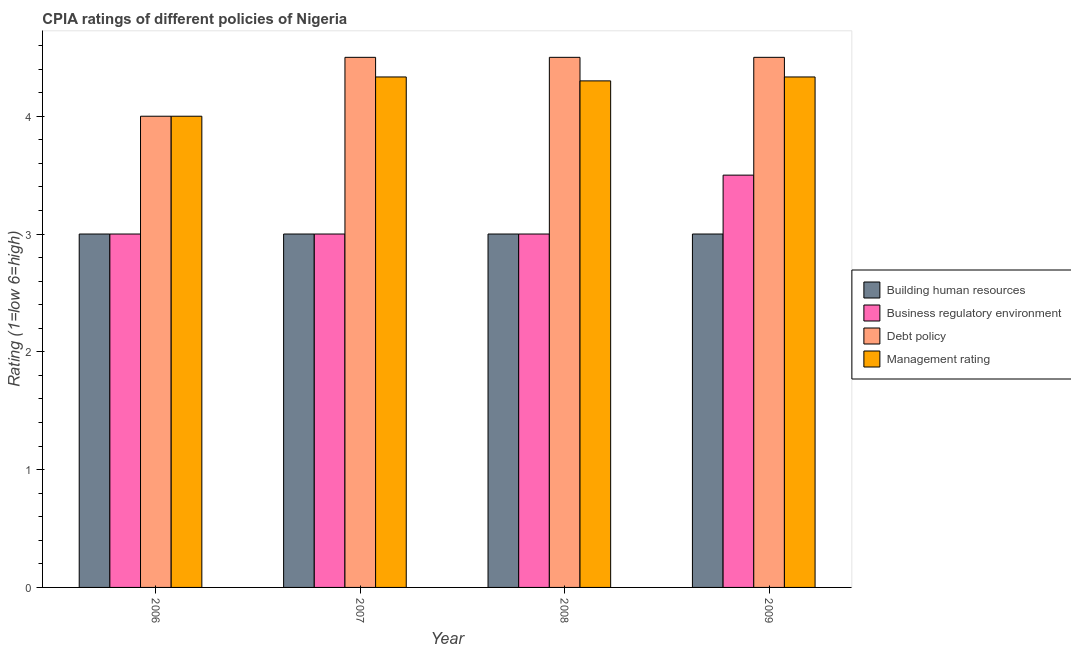How many different coloured bars are there?
Ensure brevity in your answer.  4. How many groups of bars are there?
Your answer should be compact. 4. Are the number of bars on each tick of the X-axis equal?
Make the answer very short. Yes. What is the label of the 1st group of bars from the left?
Your answer should be very brief. 2006. In how many cases, is the number of bars for a given year not equal to the number of legend labels?
Your answer should be compact. 0. In which year was the cpia rating of debt policy maximum?
Your response must be concise. 2007. What is the difference between the cpia rating of building human resources in 2006 and that in 2008?
Your answer should be very brief. 0. What is the difference between the cpia rating of management in 2007 and the cpia rating of building human resources in 2006?
Offer a terse response. 0.33. What is the average cpia rating of management per year?
Offer a very short reply. 4.24. In the year 2007, what is the difference between the cpia rating of debt policy and cpia rating of business regulatory environment?
Give a very brief answer. 0. What is the ratio of the cpia rating of building human resources in 2006 to that in 2009?
Offer a terse response. 1. Is the difference between the cpia rating of business regulatory environment in 2006 and 2009 greater than the difference between the cpia rating of management in 2006 and 2009?
Provide a succinct answer. No. What is the difference between the highest and the second highest cpia rating of building human resources?
Provide a succinct answer. 0. What is the difference between the highest and the lowest cpia rating of debt policy?
Your answer should be very brief. 0.5. In how many years, is the cpia rating of debt policy greater than the average cpia rating of debt policy taken over all years?
Provide a succinct answer. 3. Is the sum of the cpia rating of management in 2007 and 2009 greater than the maximum cpia rating of business regulatory environment across all years?
Make the answer very short. Yes. What does the 2nd bar from the left in 2006 represents?
Give a very brief answer. Business regulatory environment. What does the 3rd bar from the right in 2007 represents?
Your answer should be very brief. Business regulatory environment. How many years are there in the graph?
Offer a terse response. 4. What is the difference between two consecutive major ticks on the Y-axis?
Offer a terse response. 1. Are the values on the major ticks of Y-axis written in scientific E-notation?
Your answer should be compact. No. How many legend labels are there?
Your response must be concise. 4. How are the legend labels stacked?
Provide a short and direct response. Vertical. What is the title of the graph?
Offer a terse response. CPIA ratings of different policies of Nigeria. What is the label or title of the X-axis?
Give a very brief answer. Year. What is the Rating (1=low 6=high) in Business regulatory environment in 2006?
Your response must be concise. 3. What is the Rating (1=low 6=high) of Debt policy in 2006?
Make the answer very short. 4. What is the Rating (1=low 6=high) in Building human resources in 2007?
Provide a succinct answer. 3. What is the Rating (1=low 6=high) in Debt policy in 2007?
Ensure brevity in your answer.  4.5. What is the Rating (1=low 6=high) in Management rating in 2007?
Provide a short and direct response. 4.33. What is the Rating (1=low 6=high) of Building human resources in 2008?
Your answer should be very brief. 3. What is the Rating (1=low 6=high) in Debt policy in 2008?
Offer a terse response. 4.5. What is the Rating (1=low 6=high) of Building human resources in 2009?
Ensure brevity in your answer.  3. What is the Rating (1=low 6=high) of Business regulatory environment in 2009?
Provide a short and direct response. 3.5. What is the Rating (1=low 6=high) of Debt policy in 2009?
Make the answer very short. 4.5. What is the Rating (1=low 6=high) in Management rating in 2009?
Ensure brevity in your answer.  4.33. Across all years, what is the maximum Rating (1=low 6=high) of Business regulatory environment?
Offer a terse response. 3.5. Across all years, what is the maximum Rating (1=low 6=high) in Debt policy?
Keep it short and to the point. 4.5. Across all years, what is the maximum Rating (1=low 6=high) of Management rating?
Keep it short and to the point. 4.33. Across all years, what is the minimum Rating (1=low 6=high) of Building human resources?
Your answer should be very brief. 3. What is the total Rating (1=low 6=high) in Building human resources in the graph?
Keep it short and to the point. 12. What is the total Rating (1=low 6=high) of Management rating in the graph?
Make the answer very short. 16.97. What is the difference between the Rating (1=low 6=high) of Business regulatory environment in 2006 and that in 2007?
Provide a succinct answer. 0. What is the difference between the Rating (1=low 6=high) in Debt policy in 2006 and that in 2007?
Your response must be concise. -0.5. What is the difference between the Rating (1=low 6=high) of Business regulatory environment in 2006 and that in 2008?
Give a very brief answer. 0. What is the difference between the Rating (1=low 6=high) of Debt policy in 2006 and that in 2008?
Keep it short and to the point. -0.5. What is the difference between the Rating (1=low 6=high) in Management rating in 2006 and that in 2008?
Keep it short and to the point. -0.3. What is the difference between the Rating (1=low 6=high) of Business regulatory environment in 2006 and that in 2009?
Make the answer very short. -0.5. What is the difference between the Rating (1=low 6=high) of Management rating in 2006 and that in 2009?
Offer a very short reply. -0.33. What is the difference between the Rating (1=low 6=high) in Building human resources in 2007 and that in 2008?
Your answer should be very brief. 0. What is the difference between the Rating (1=low 6=high) in Debt policy in 2007 and that in 2008?
Keep it short and to the point. 0. What is the difference between the Rating (1=low 6=high) in Management rating in 2007 and that in 2008?
Offer a terse response. 0.03. What is the difference between the Rating (1=low 6=high) of Building human resources in 2007 and that in 2009?
Your response must be concise. 0. What is the difference between the Rating (1=low 6=high) in Debt policy in 2007 and that in 2009?
Make the answer very short. 0. What is the difference between the Rating (1=low 6=high) of Business regulatory environment in 2008 and that in 2009?
Keep it short and to the point. -0.5. What is the difference between the Rating (1=low 6=high) in Debt policy in 2008 and that in 2009?
Your answer should be very brief. 0. What is the difference between the Rating (1=low 6=high) in Management rating in 2008 and that in 2009?
Offer a terse response. -0.03. What is the difference between the Rating (1=low 6=high) of Building human resources in 2006 and the Rating (1=low 6=high) of Management rating in 2007?
Your answer should be compact. -1.33. What is the difference between the Rating (1=low 6=high) of Business regulatory environment in 2006 and the Rating (1=low 6=high) of Debt policy in 2007?
Your response must be concise. -1.5. What is the difference between the Rating (1=low 6=high) in Business regulatory environment in 2006 and the Rating (1=low 6=high) in Management rating in 2007?
Provide a short and direct response. -1.33. What is the difference between the Rating (1=low 6=high) of Building human resources in 2006 and the Rating (1=low 6=high) of Business regulatory environment in 2008?
Give a very brief answer. 0. What is the difference between the Rating (1=low 6=high) in Business regulatory environment in 2006 and the Rating (1=low 6=high) in Management rating in 2008?
Your response must be concise. -1.3. What is the difference between the Rating (1=low 6=high) of Debt policy in 2006 and the Rating (1=low 6=high) of Management rating in 2008?
Your response must be concise. -0.3. What is the difference between the Rating (1=low 6=high) of Building human resources in 2006 and the Rating (1=low 6=high) of Business regulatory environment in 2009?
Ensure brevity in your answer.  -0.5. What is the difference between the Rating (1=low 6=high) of Building human resources in 2006 and the Rating (1=low 6=high) of Debt policy in 2009?
Keep it short and to the point. -1.5. What is the difference between the Rating (1=low 6=high) of Building human resources in 2006 and the Rating (1=low 6=high) of Management rating in 2009?
Keep it short and to the point. -1.33. What is the difference between the Rating (1=low 6=high) in Business regulatory environment in 2006 and the Rating (1=low 6=high) in Debt policy in 2009?
Provide a short and direct response. -1.5. What is the difference between the Rating (1=low 6=high) of Business regulatory environment in 2006 and the Rating (1=low 6=high) of Management rating in 2009?
Your answer should be compact. -1.33. What is the difference between the Rating (1=low 6=high) in Debt policy in 2006 and the Rating (1=low 6=high) in Management rating in 2009?
Provide a short and direct response. -0.33. What is the difference between the Rating (1=low 6=high) of Building human resources in 2007 and the Rating (1=low 6=high) of Business regulatory environment in 2008?
Give a very brief answer. 0. What is the difference between the Rating (1=low 6=high) in Building human resources in 2007 and the Rating (1=low 6=high) in Management rating in 2008?
Offer a very short reply. -1.3. What is the difference between the Rating (1=low 6=high) in Building human resources in 2007 and the Rating (1=low 6=high) in Management rating in 2009?
Provide a succinct answer. -1.33. What is the difference between the Rating (1=low 6=high) in Business regulatory environment in 2007 and the Rating (1=low 6=high) in Debt policy in 2009?
Your answer should be compact. -1.5. What is the difference between the Rating (1=low 6=high) in Business regulatory environment in 2007 and the Rating (1=low 6=high) in Management rating in 2009?
Give a very brief answer. -1.33. What is the difference between the Rating (1=low 6=high) of Building human resources in 2008 and the Rating (1=low 6=high) of Business regulatory environment in 2009?
Your answer should be compact. -0.5. What is the difference between the Rating (1=low 6=high) in Building human resources in 2008 and the Rating (1=low 6=high) in Debt policy in 2009?
Provide a succinct answer. -1.5. What is the difference between the Rating (1=low 6=high) of Building human resources in 2008 and the Rating (1=low 6=high) of Management rating in 2009?
Give a very brief answer. -1.33. What is the difference between the Rating (1=low 6=high) of Business regulatory environment in 2008 and the Rating (1=low 6=high) of Management rating in 2009?
Your response must be concise. -1.33. What is the average Rating (1=low 6=high) of Business regulatory environment per year?
Keep it short and to the point. 3.12. What is the average Rating (1=low 6=high) of Debt policy per year?
Your answer should be very brief. 4.38. What is the average Rating (1=low 6=high) in Management rating per year?
Offer a very short reply. 4.24. In the year 2006, what is the difference between the Rating (1=low 6=high) in Building human resources and Rating (1=low 6=high) in Business regulatory environment?
Give a very brief answer. 0. In the year 2006, what is the difference between the Rating (1=low 6=high) of Business regulatory environment and Rating (1=low 6=high) of Debt policy?
Offer a terse response. -1. In the year 2007, what is the difference between the Rating (1=low 6=high) of Building human resources and Rating (1=low 6=high) of Business regulatory environment?
Keep it short and to the point. 0. In the year 2007, what is the difference between the Rating (1=low 6=high) in Building human resources and Rating (1=low 6=high) in Debt policy?
Your answer should be compact. -1.5. In the year 2007, what is the difference between the Rating (1=low 6=high) of Building human resources and Rating (1=low 6=high) of Management rating?
Your response must be concise. -1.33. In the year 2007, what is the difference between the Rating (1=low 6=high) in Business regulatory environment and Rating (1=low 6=high) in Management rating?
Offer a very short reply. -1.33. In the year 2008, what is the difference between the Rating (1=low 6=high) in Building human resources and Rating (1=low 6=high) in Debt policy?
Keep it short and to the point. -1.5. In the year 2008, what is the difference between the Rating (1=low 6=high) in Building human resources and Rating (1=low 6=high) in Management rating?
Offer a very short reply. -1.3. In the year 2008, what is the difference between the Rating (1=low 6=high) of Business regulatory environment and Rating (1=low 6=high) of Management rating?
Offer a terse response. -1.3. In the year 2009, what is the difference between the Rating (1=low 6=high) of Building human resources and Rating (1=low 6=high) of Debt policy?
Give a very brief answer. -1.5. In the year 2009, what is the difference between the Rating (1=low 6=high) in Building human resources and Rating (1=low 6=high) in Management rating?
Offer a terse response. -1.33. In the year 2009, what is the difference between the Rating (1=low 6=high) of Business regulatory environment and Rating (1=low 6=high) of Management rating?
Provide a short and direct response. -0.83. In the year 2009, what is the difference between the Rating (1=low 6=high) of Debt policy and Rating (1=low 6=high) of Management rating?
Your response must be concise. 0.17. What is the ratio of the Rating (1=low 6=high) of Business regulatory environment in 2006 to that in 2007?
Offer a terse response. 1. What is the ratio of the Rating (1=low 6=high) of Debt policy in 2006 to that in 2007?
Your answer should be compact. 0.89. What is the ratio of the Rating (1=low 6=high) in Management rating in 2006 to that in 2007?
Offer a terse response. 0.92. What is the ratio of the Rating (1=low 6=high) in Building human resources in 2006 to that in 2008?
Provide a succinct answer. 1. What is the ratio of the Rating (1=low 6=high) in Business regulatory environment in 2006 to that in 2008?
Your answer should be very brief. 1. What is the ratio of the Rating (1=low 6=high) of Management rating in 2006 to that in 2008?
Offer a very short reply. 0.93. What is the ratio of the Rating (1=low 6=high) of Building human resources in 2006 to that in 2009?
Your response must be concise. 1. What is the ratio of the Rating (1=low 6=high) in Business regulatory environment in 2007 to that in 2008?
Ensure brevity in your answer.  1. What is the ratio of the Rating (1=low 6=high) of Building human resources in 2007 to that in 2009?
Offer a very short reply. 1. What is the ratio of the Rating (1=low 6=high) of Debt policy in 2008 to that in 2009?
Provide a short and direct response. 1. What is the difference between the highest and the second highest Rating (1=low 6=high) in Business regulatory environment?
Your response must be concise. 0.5. What is the difference between the highest and the lowest Rating (1=low 6=high) of Debt policy?
Give a very brief answer. 0.5. 